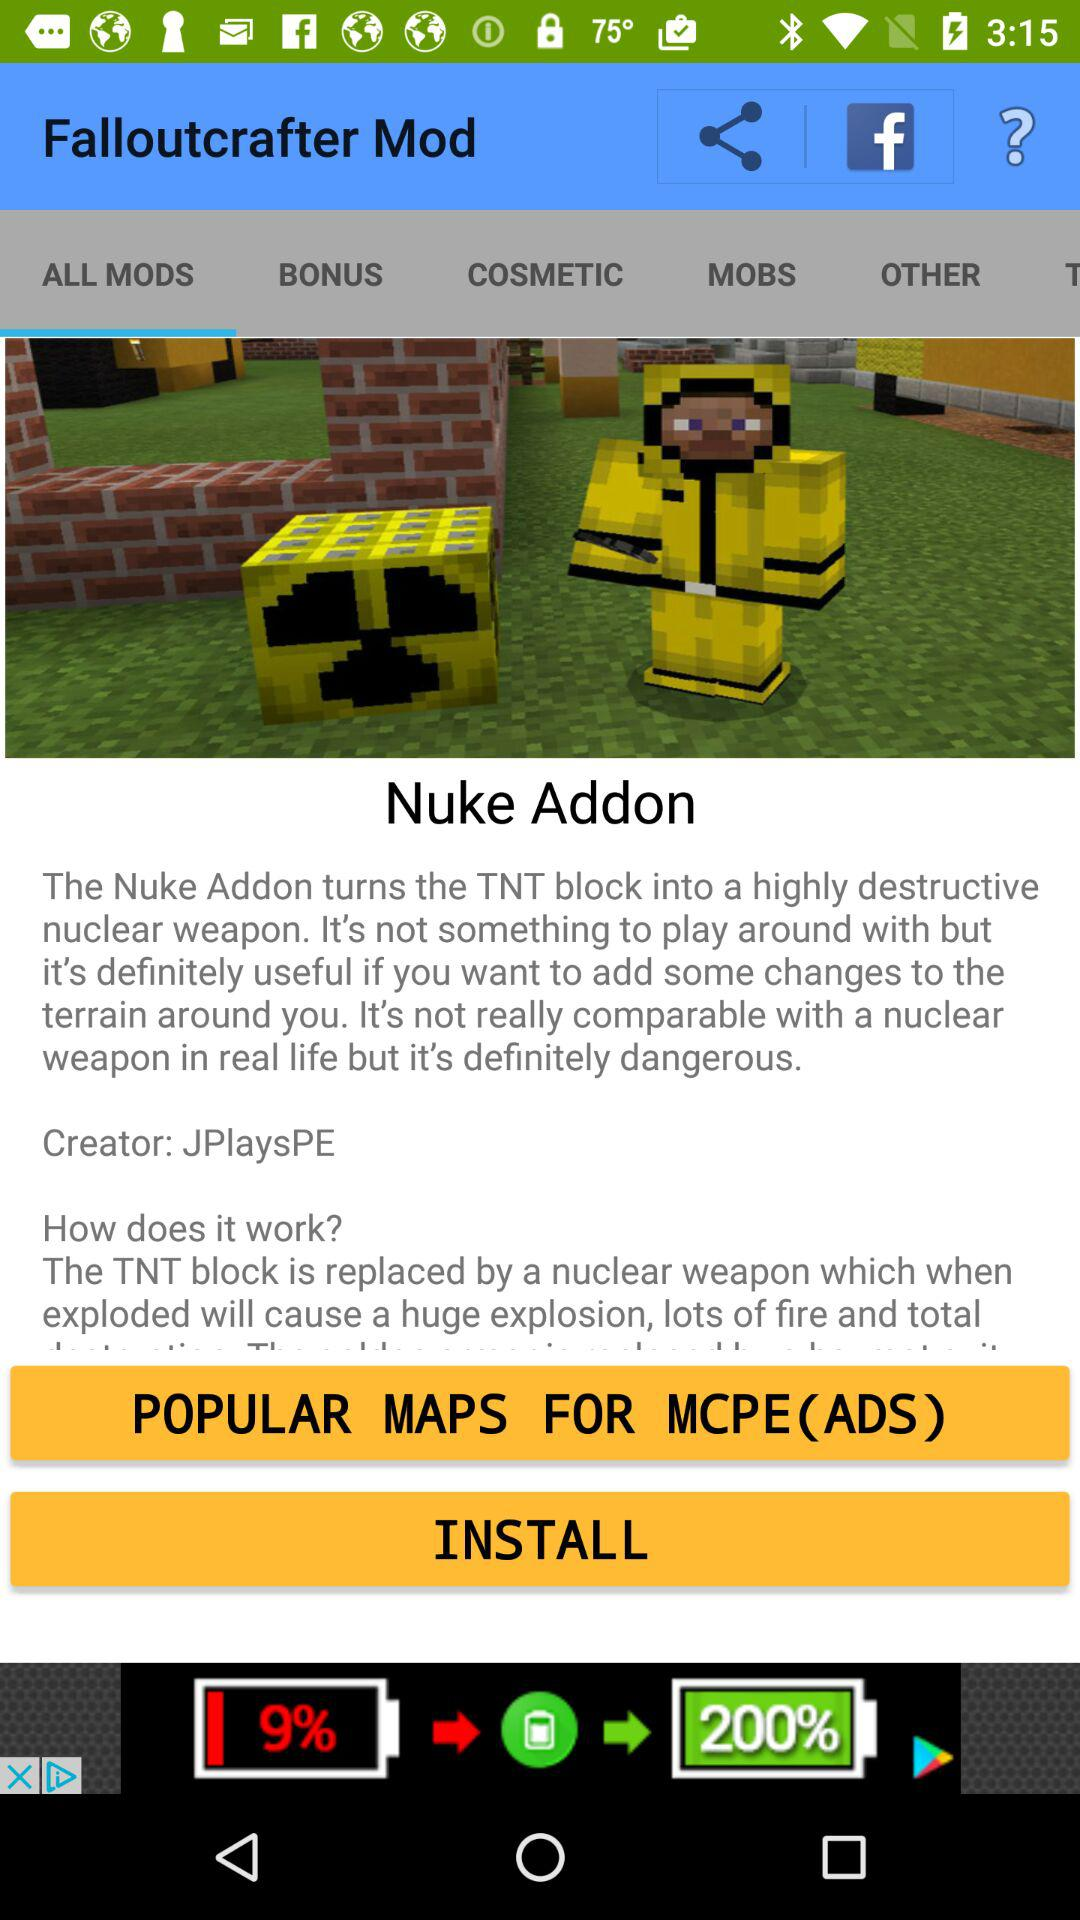What is the app name? The app names are "Falloutcrafter Mod" and "Nuke Addon". 